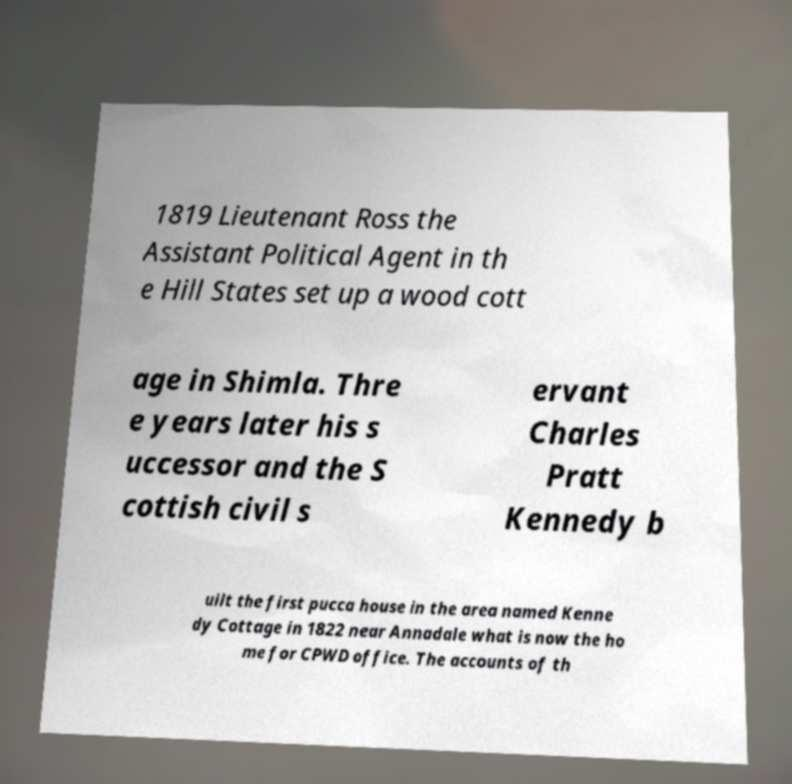I need the written content from this picture converted into text. Can you do that? 1819 Lieutenant Ross the Assistant Political Agent in th e Hill States set up a wood cott age in Shimla. Thre e years later his s uccessor and the S cottish civil s ervant Charles Pratt Kennedy b uilt the first pucca house in the area named Kenne dy Cottage in 1822 near Annadale what is now the ho me for CPWD office. The accounts of th 